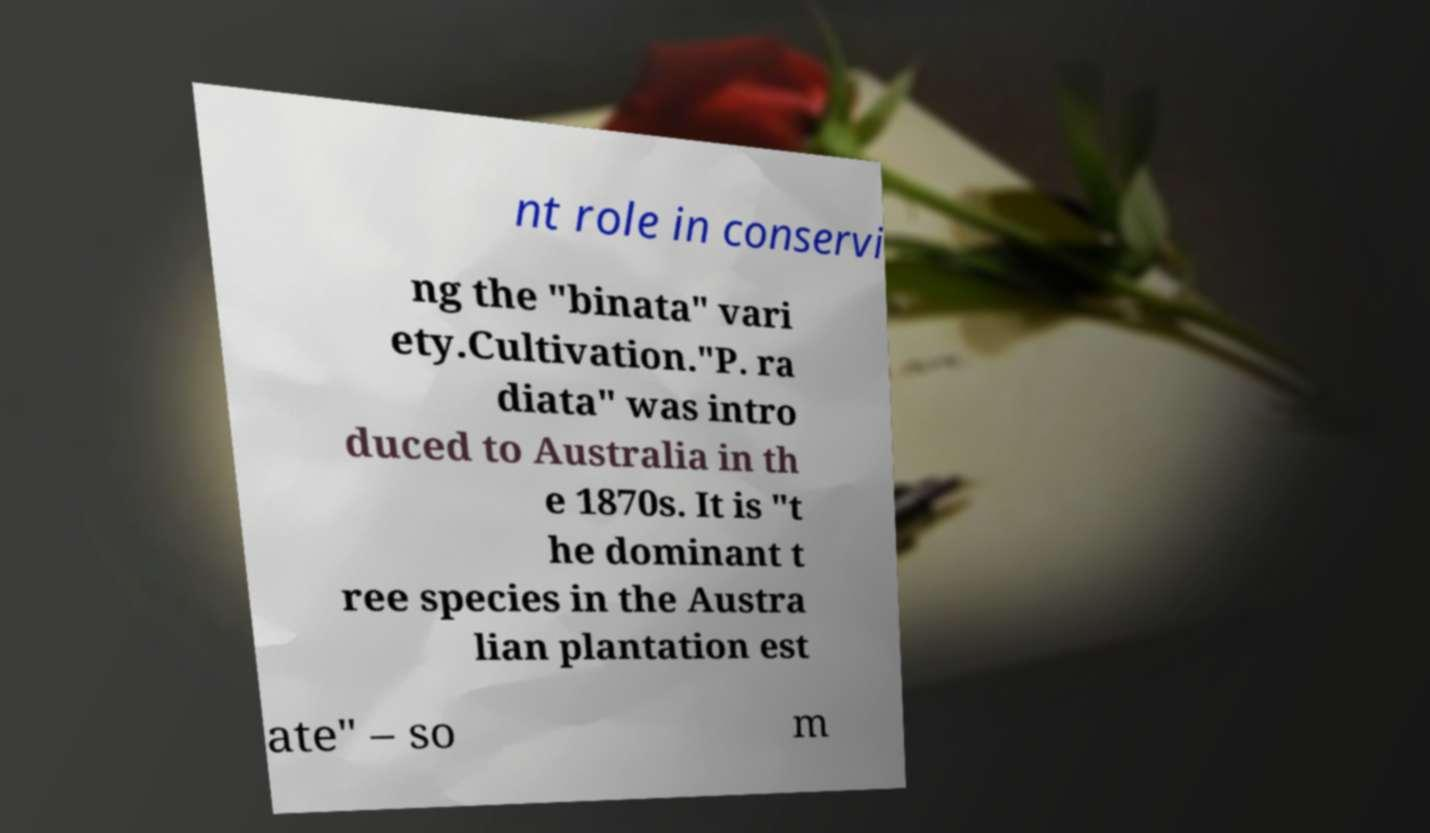What messages or text are displayed in this image? I need them in a readable, typed format. nt role in conservi ng the "binata" vari ety.Cultivation."P. ra diata" was intro duced to Australia in th e 1870s. It is "t he dominant t ree species in the Austra lian plantation est ate" – so m 